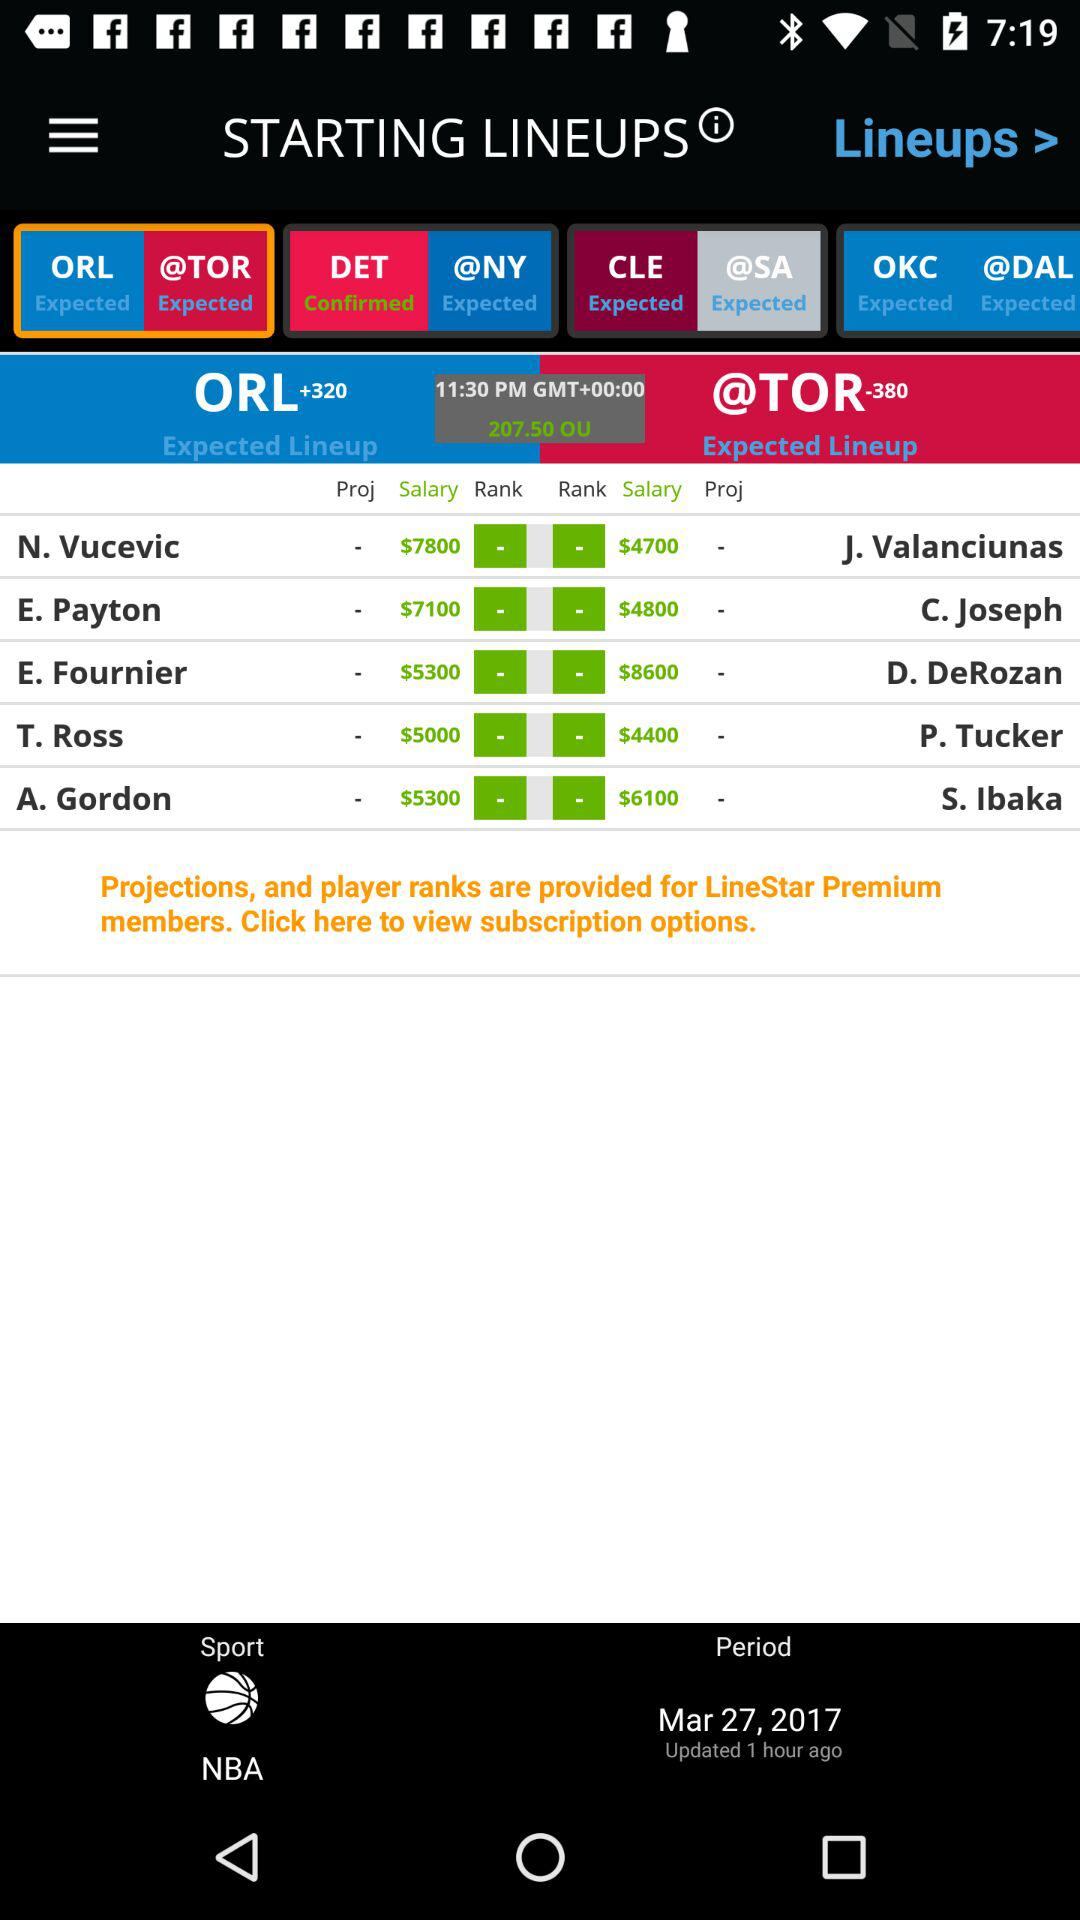What is the date? The date is March 27, 2017. 